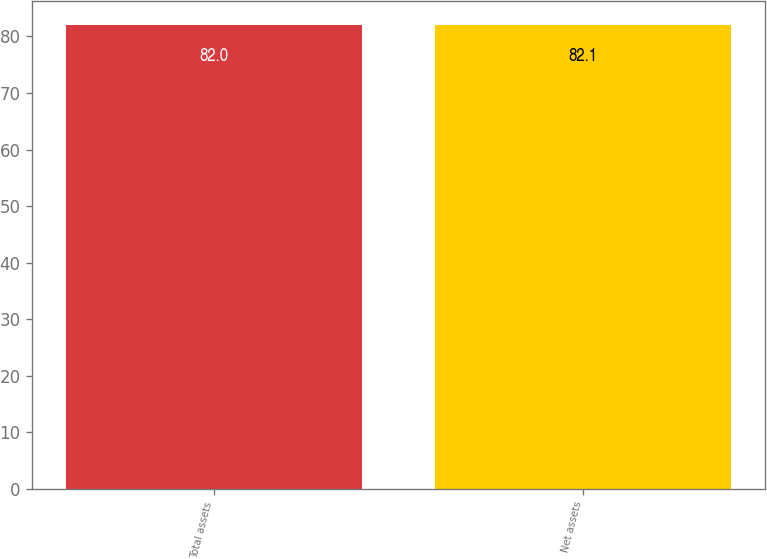Convert chart. <chart><loc_0><loc_0><loc_500><loc_500><bar_chart><fcel>Total assets<fcel>Net assets<nl><fcel>82<fcel>82.1<nl></chart> 